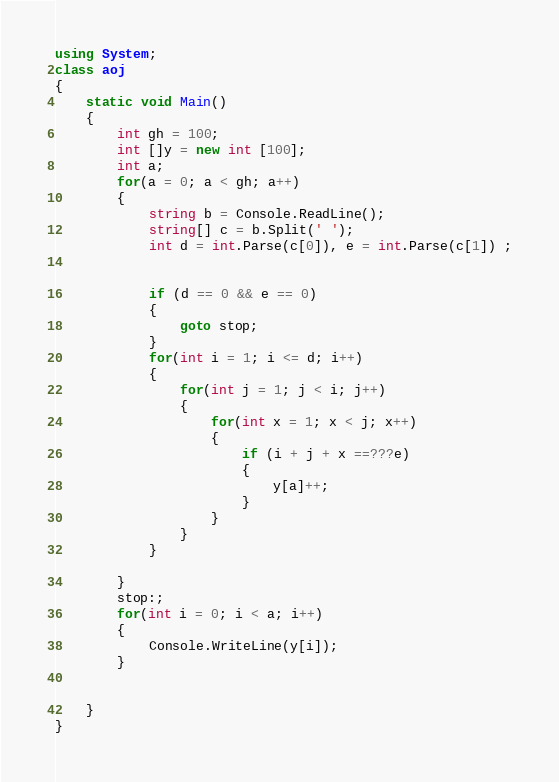Convert code to text. <code><loc_0><loc_0><loc_500><loc_500><_C#_>using System;
class aoj
{
    static void Main()
    {
        int gh = 100;
        int []y = new int [100];
        int a;
        for(a = 0; a < gh; a++)
        {
            string b = Console.ReadLine();
            string[] c = b.Split(' ');
            int d = int.Parse(c[0]), e = int.Parse(c[1]) ;
            
            
            if (d == 0 && e == 0)
            {
                goto stop;
            }
            for(int i = 1; i <= d; i++)
            {
                for(int j = 1; j < i; j++)
                {
                    for(int x = 1; x < j; x++)
                    {
                        if (i + j + x ==???e)
                        {
                            y[a]++;
                        }
                    }
                }
            }
            
        }
        stop:;
        for(int i = 0; i < a; i++)
        {
            Console.WriteLine(y[i]);
        }
        
       
    }
}</code> 